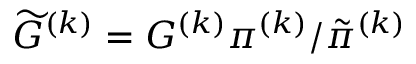Convert formula to latex. <formula><loc_0><loc_0><loc_500><loc_500>\widetilde { G } ^ { ( k ) } = G ^ { ( k ) } \pi ^ { ( k ) } / \tilde { \pi } ^ { ( k ) }</formula> 